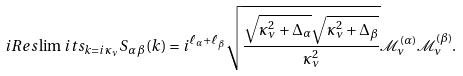<formula> <loc_0><loc_0><loc_500><loc_500>i R e s \lim i t s _ { k = i \kappa _ { \nu } } S _ { \alpha \, \beta } ( k ) = i ^ { \ell _ { \alpha } + \ell _ { \beta } } \sqrt { \frac { \sqrt { \kappa _ { \nu } ^ { 2 } + \Delta _ { \alpha } } \sqrt { \kappa _ { \nu } ^ { 2 } + \Delta _ { \beta } } } { \kappa _ { \nu } ^ { 2 } } } \mathcal { M } ^ { ( \alpha ) } _ { \nu } \mathcal { M } ^ { ( \beta ) } _ { \nu } .</formula> 